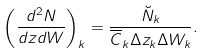Convert formula to latex. <formula><loc_0><loc_0><loc_500><loc_500>\left ( \frac { d ^ { 2 } N } { d z d W } \right ) _ { k } = \frac { \breve { N } _ { k } } { \overline { C } _ { k } \Delta z _ { k } \Delta W _ { k } } .</formula> 